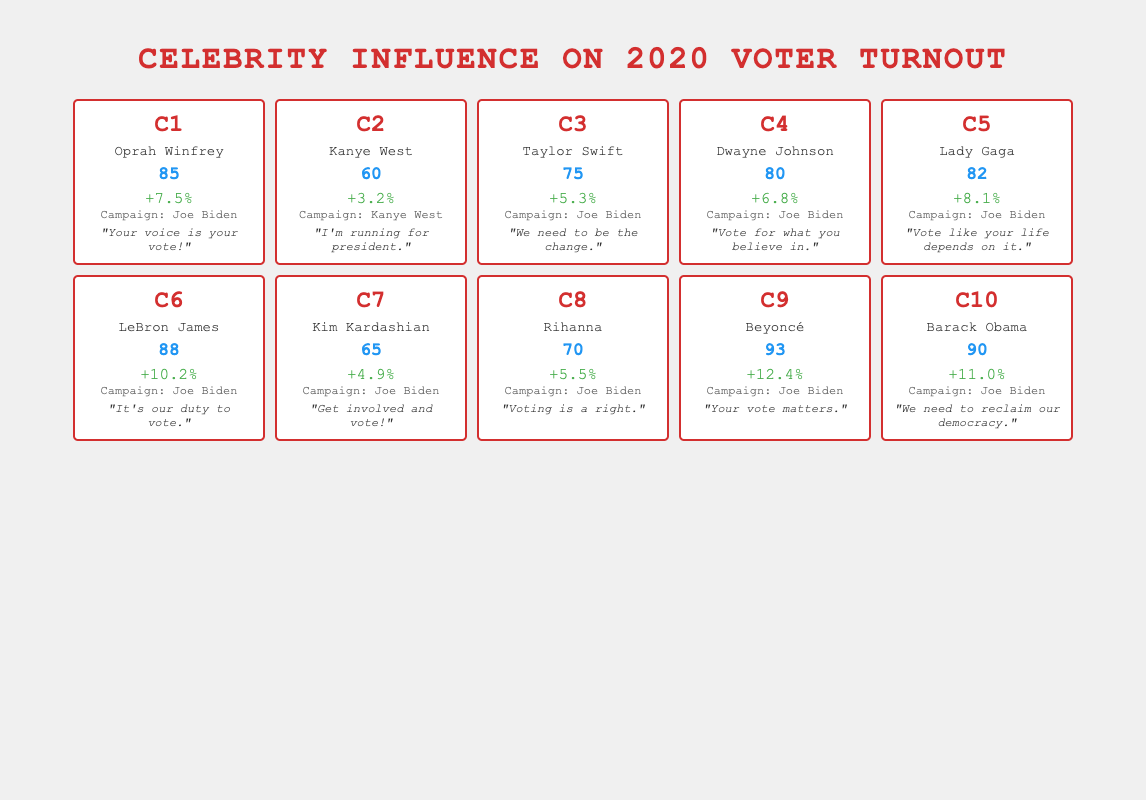What was the influence score of Beyoncé? In the table, the influence score for Beyoncé is clearly stated in the "influence_score" column. Referring directly to that, the score is 93.
Answer: 93 Which celebrity had the highest voter turnout increase? By looking at the "voter_turnout" column, I identify the highest value. The maximum voter turnout increase is +12.4%, which is attributed to Beyoncé.
Answer: Beyoncé What is the average influence score of celebrities who campaigned for Joe Biden? First, I would identify all celebrities who supported Joe Biden and note their influence scores: Oprah Winfrey (85), Taylor Swift (75), Dwayne Johnson (80), Lady Gaga (82), LeBron James (88), Kim Kardashian (65), Rihanna (70), Beyoncé (93), Barack Obama (90). Then, I sum them: 85 + 75 + 80 + 82 + 88 + 65 + 70 + 93 + 90 = 823. There are 9 celebrities, so the average is 823 / 9 = approximately 91.44.
Answer: 91.44 Did Kim Kardashian have a higher influence score than Taylor Swift? I can directly compare the influence scores from the table: Kim Kardashian has an influence score of 65, while Taylor Swift has a score of 75. Since 65 is not greater than 75, the answer is no.
Answer: No Which celebrity's notable quote emphasized the importance of voting? Reviewing the notable quotes, Beyoncé's quote "Your vote matters" specifically emphasizes the importance of voting. Others also mention voting, but hers is a direct affirmation of its significance.
Answer: Beyoncé 